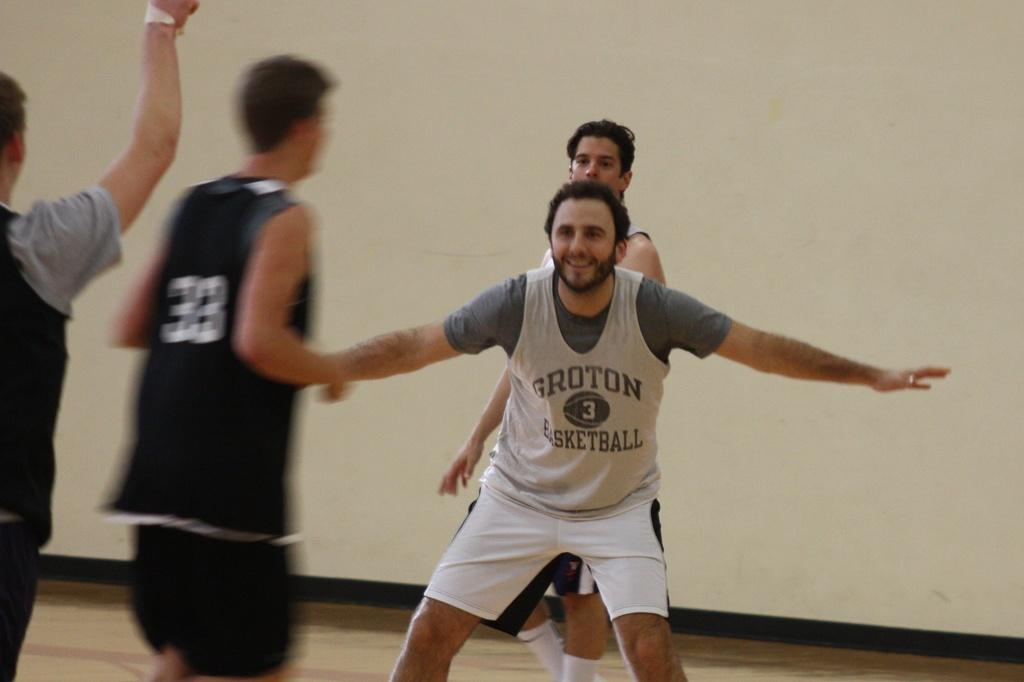<image>
Render a clear and concise summary of the photo. a boy wearing a jersey that says 'groton basketball' on it 